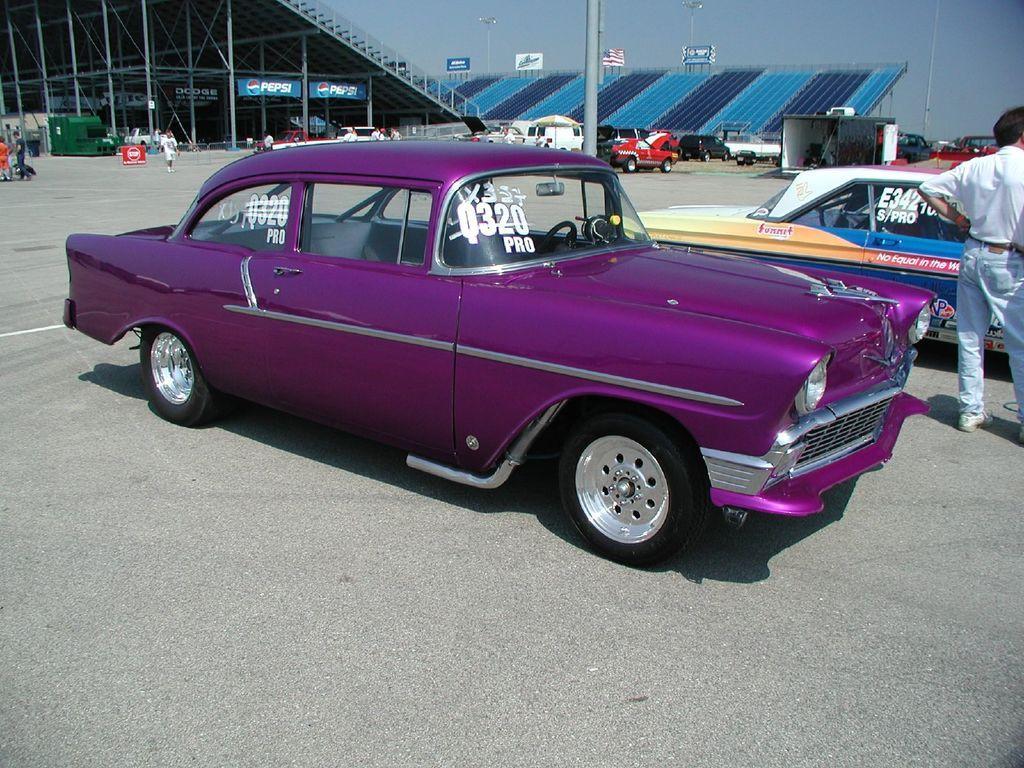Please provide a concise description of this image. This picture is clicked outside. In the center we can see the group of vehicles parked on the ground and we can see the group of persons, shed, metal rods, banners on which we can see the text. In the background we can see the sky, lights and many other objects. 